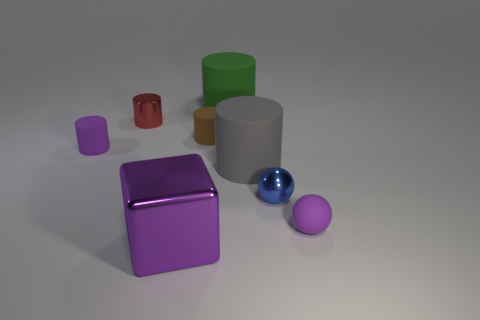There is a tiny matte object that is on the right side of the tiny brown object; is it the same color as the metal block?
Ensure brevity in your answer.  Yes. What number of large metallic objects have the same color as the tiny rubber sphere?
Offer a very short reply. 1. What is the shape of the tiny metallic thing that is to the right of the big object in front of the tiny blue thing?
Your response must be concise. Sphere. Are there any other things that are the same shape as the gray object?
Make the answer very short. Yes. The other big thing that is the same shape as the big gray thing is what color?
Ensure brevity in your answer.  Green. There is a small matte ball; is its color the same as the metal object in front of the tiny purple matte ball?
Offer a terse response. Yes. The object that is to the left of the blue metal thing and in front of the small blue shiny ball has what shape?
Provide a short and direct response. Cube. Are there fewer brown things than yellow matte spheres?
Ensure brevity in your answer.  No. Are there any red metal cubes?
Make the answer very short. No. How many other objects are the same size as the blue metallic object?
Make the answer very short. 4. 